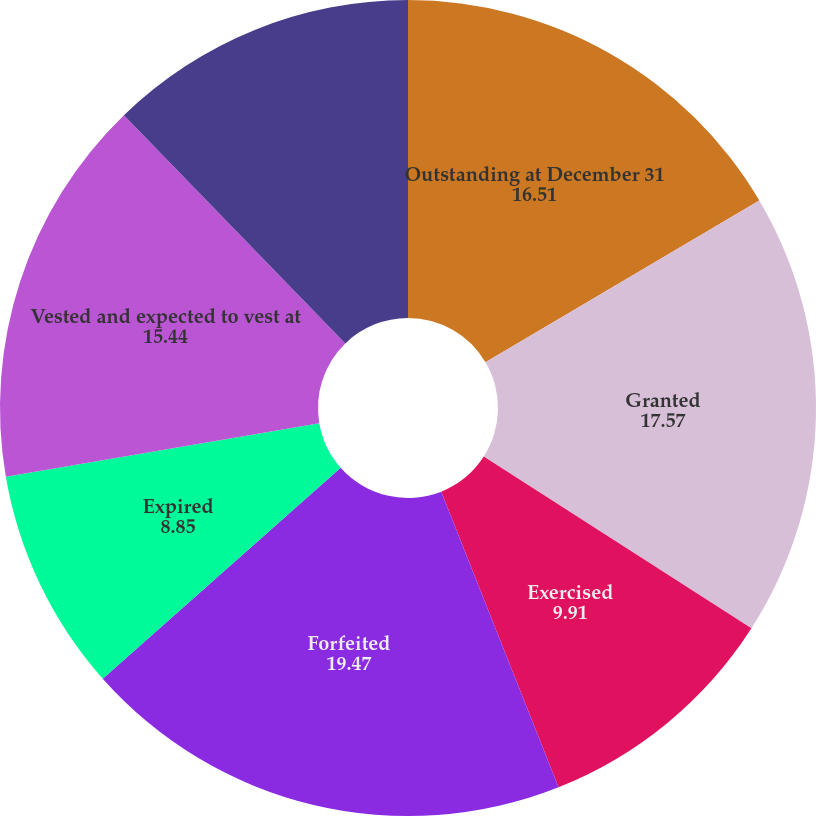<chart> <loc_0><loc_0><loc_500><loc_500><pie_chart><fcel>Outstanding at December 31<fcel>Granted<fcel>Exercised<fcel>Forfeited<fcel>Expired<fcel>Vested and expected to vest at<fcel>Exercisable at December 31<nl><fcel>16.51%<fcel>17.57%<fcel>9.91%<fcel>19.47%<fcel>8.85%<fcel>15.44%<fcel>12.26%<nl></chart> 